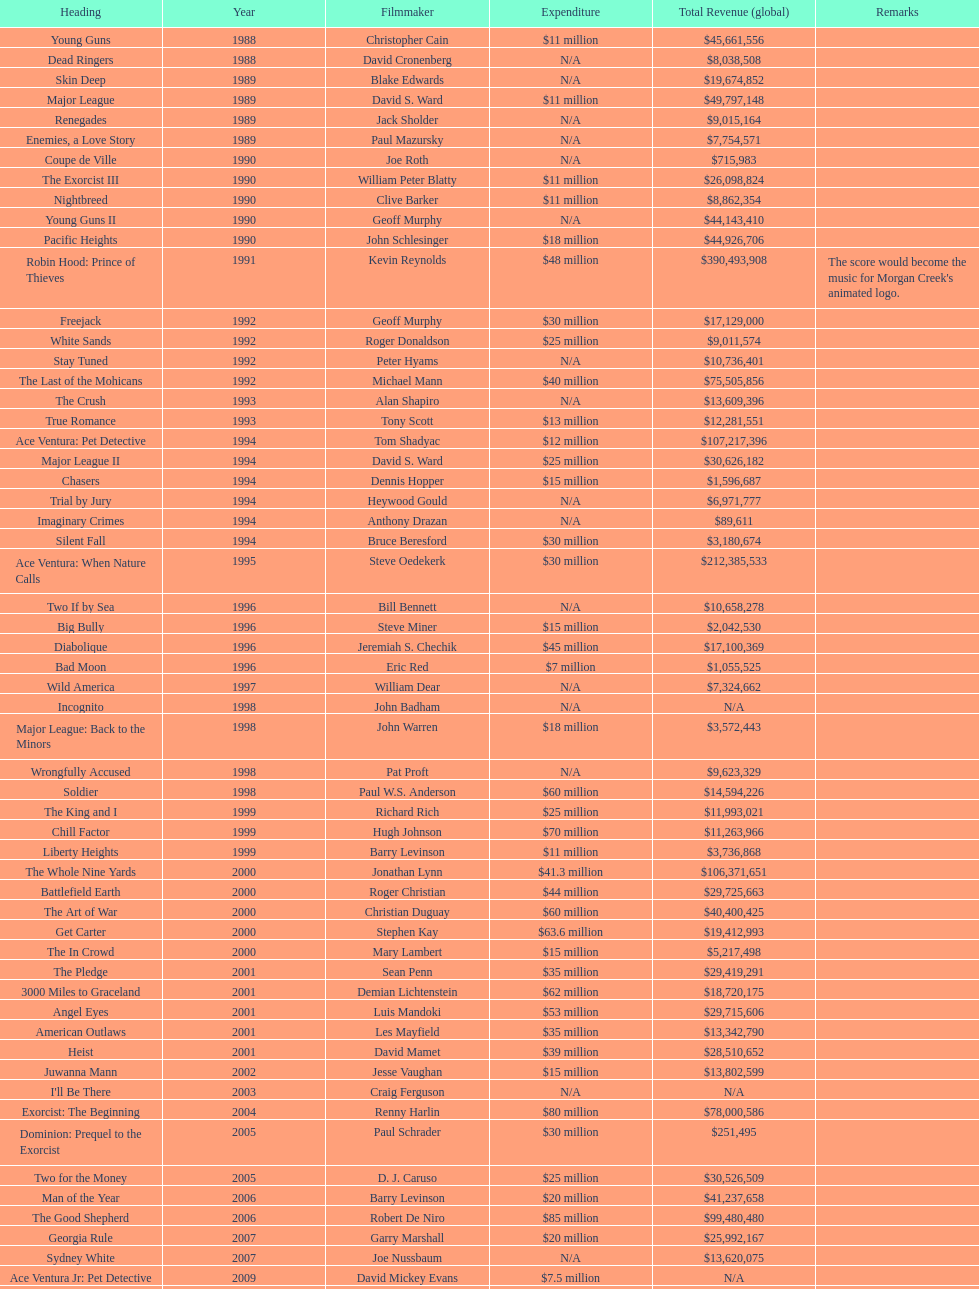How many films were there in 1990? 5. 